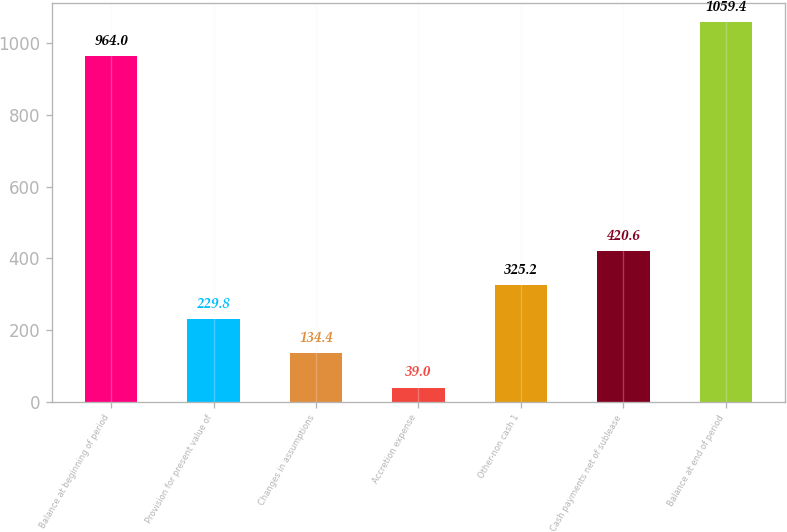<chart> <loc_0><loc_0><loc_500><loc_500><bar_chart><fcel>Balance at beginning of period<fcel>Provision for present value of<fcel>Changes in assumptions<fcel>Accretion expense<fcel>Other-non cash 1<fcel>Cash payments net of sublease<fcel>Balance at end of period<nl><fcel>964<fcel>229.8<fcel>134.4<fcel>39<fcel>325.2<fcel>420.6<fcel>1059.4<nl></chart> 